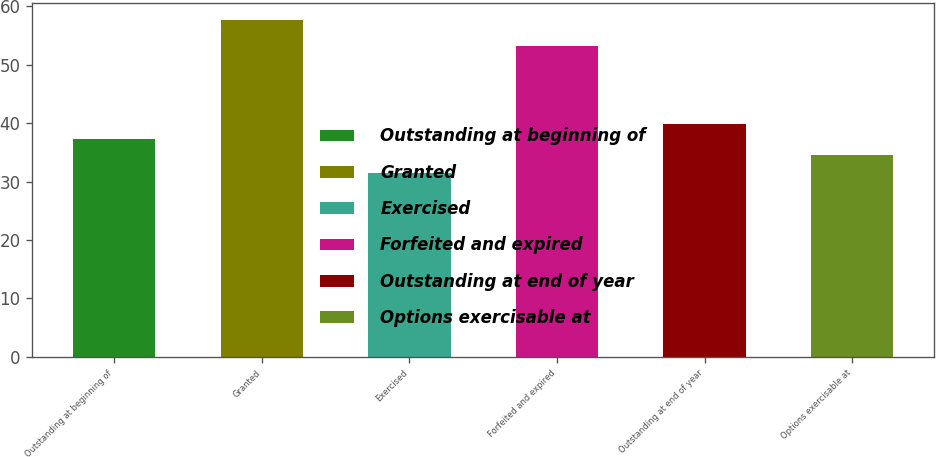Convert chart. <chart><loc_0><loc_0><loc_500><loc_500><bar_chart><fcel>Outstanding at beginning of<fcel>Granted<fcel>Exercised<fcel>Forfeited and expired<fcel>Outstanding at end of year<fcel>Options exercisable at<nl><fcel>37.22<fcel>57.71<fcel>31.5<fcel>53.23<fcel>39.84<fcel>34.6<nl></chart> 